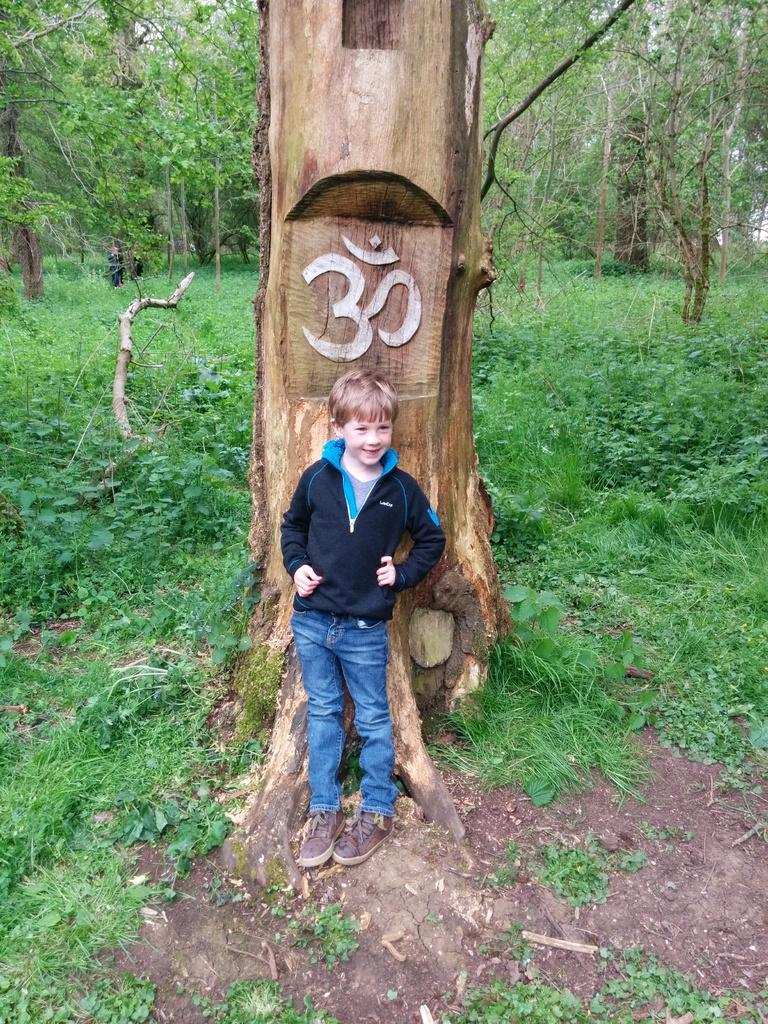Who is present in the image? There is a boy in the image. What is the boy doing in the image? The boy is standing on the ground and smiling. What type of surface is the boy standing on? The boy is standing on grass in the image. What can be seen on the tree trunk in the image? There is a symbol on a tree trunk in the image. What is visible in the background of the image? There are people and trees in the background of the image. What type of button is the boy wearing on his shirt in the image? There is no button visible on the boy's shirt in the image. What knowledge does the boy possess about silver in the image? There is no indication in the image that the boy possesses any knowledge about silver. 